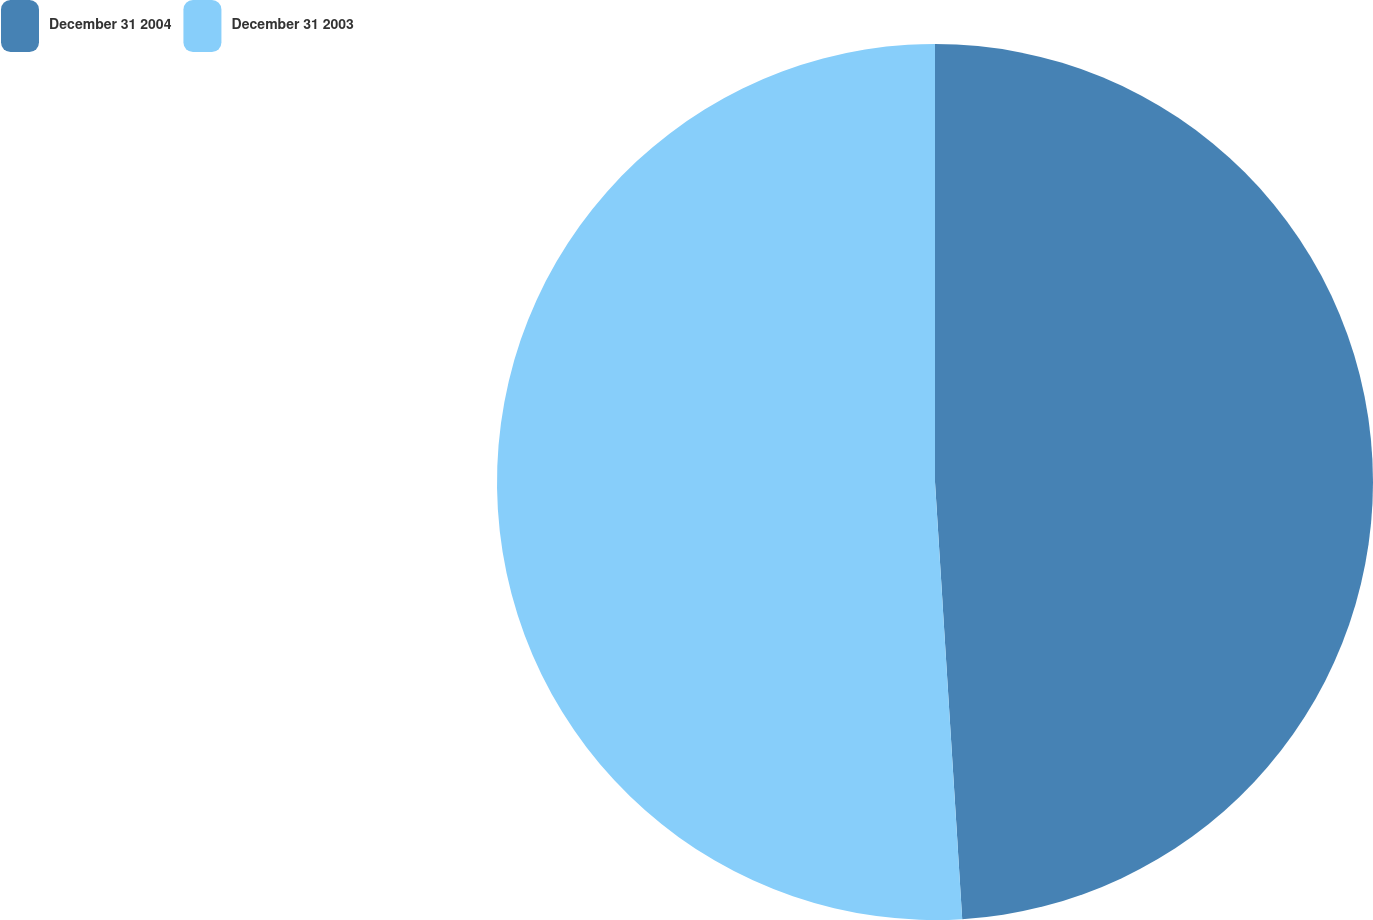<chart> <loc_0><loc_0><loc_500><loc_500><pie_chart><fcel>December 31 2004<fcel>December 31 2003<nl><fcel>49.01%<fcel>50.99%<nl></chart> 